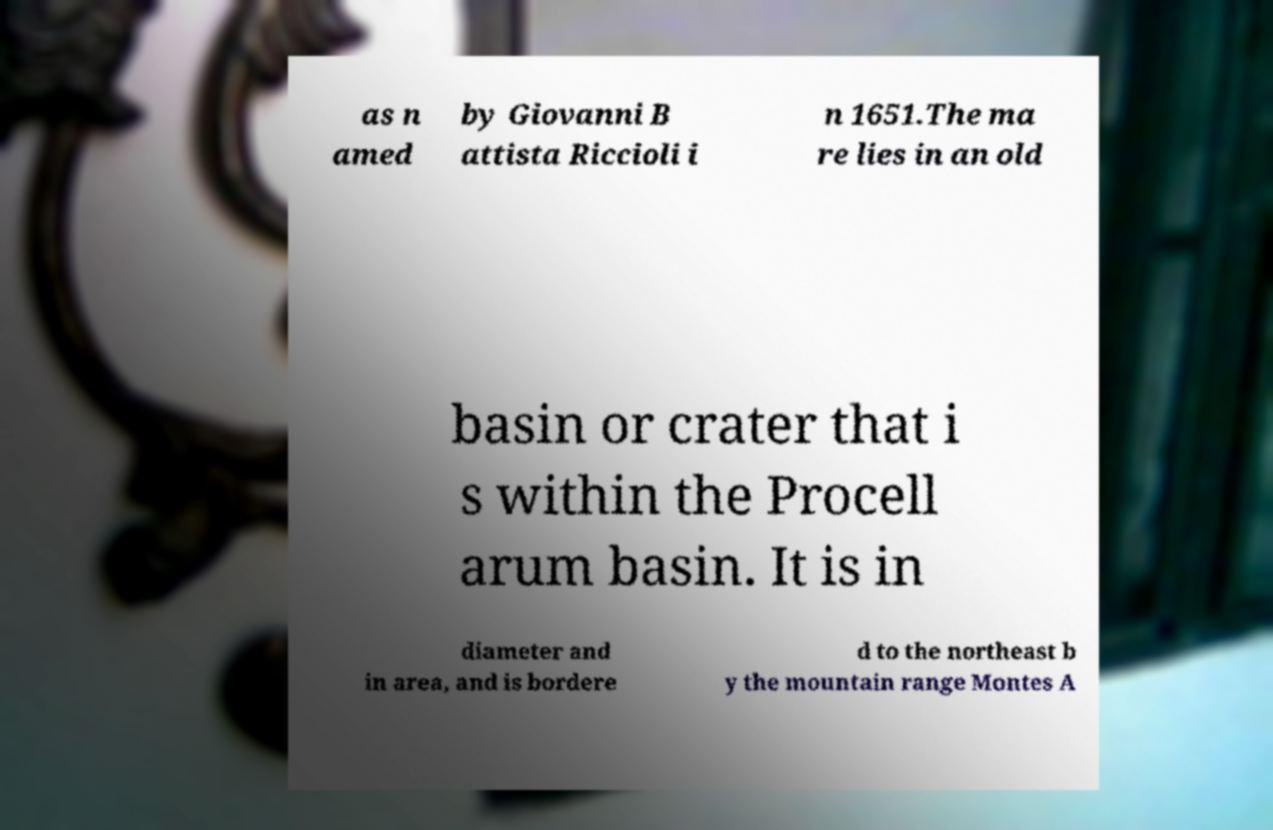Can you read and provide the text displayed in the image?This photo seems to have some interesting text. Can you extract and type it out for me? as n amed by Giovanni B attista Riccioli i n 1651.The ma re lies in an old basin or crater that i s within the Procell arum basin. It is in diameter and in area, and is bordere d to the northeast b y the mountain range Montes A 